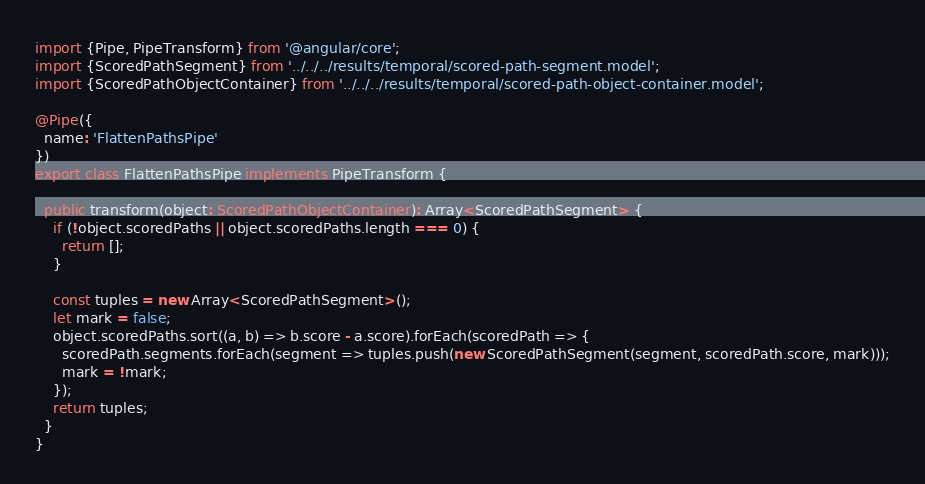Convert code to text. <code><loc_0><loc_0><loc_500><loc_500><_TypeScript_>import {Pipe, PipeTransform} from '@angular/core';
import {ScoredPathSegment} from '../../../results/temporal/scored-path-segment.model';
import {ScoredPathObjectContainer} from '../../../results/temporal/scored-path-object-container.model';

@Pipe({
  name: 'FlattenPathsPipe'
})
export class FlattenPathsPipe implements PipeTransform {

  public transform(object: ScoredPathObjectContainer): Array<ScoredPathSegment> {
    if (!object.scoredPaths || object.scoredPaths.length === 0) {
      return [];
    }

    const tuples = new Array<ScoredPathSegment>();
    let mark = false;
    object.scoredPaths.sort((a, b) => b.score - a.score).forEach(scoredPath => {
      scoredPath.segments.forEach(segment => tuples.push(new ScoredPathSegment(segment, scoredPath.score, mark)));
      mark = !mark;
    });
    return tuples;
  }
}
</code> 